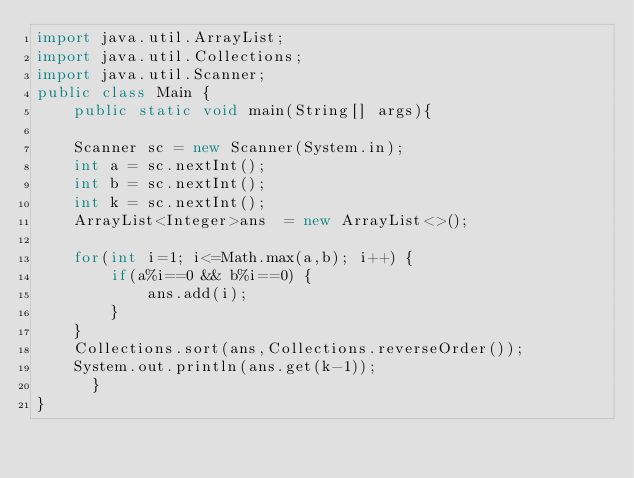Convert code to text. <code><loc_0><loc_0><loc_500><loc_500><_Java_>import java.util.ArrayList;
import java.util.Collections;
import java.util.Scanner;
public class Main {
    public static void main(String[] args){
    
    Scanner sc = new Scanner(System.in);
    int a = sc.nextInt();
    int b = sc.nextInt();
    int k = sc.nextInt();
    ArrayList<Integer>ans  = new ArrayList<>();
    
    for(int i=1; i<=Math.max(a,b); i++) {
    	if(a%i==0 && b%i==0) {
    		ans.add(i);
    	}
    }
    Collections.sort(ans,Collections.reverseOrder());
	System.out.println(ans.get(k-1));
      }
}
</code> 